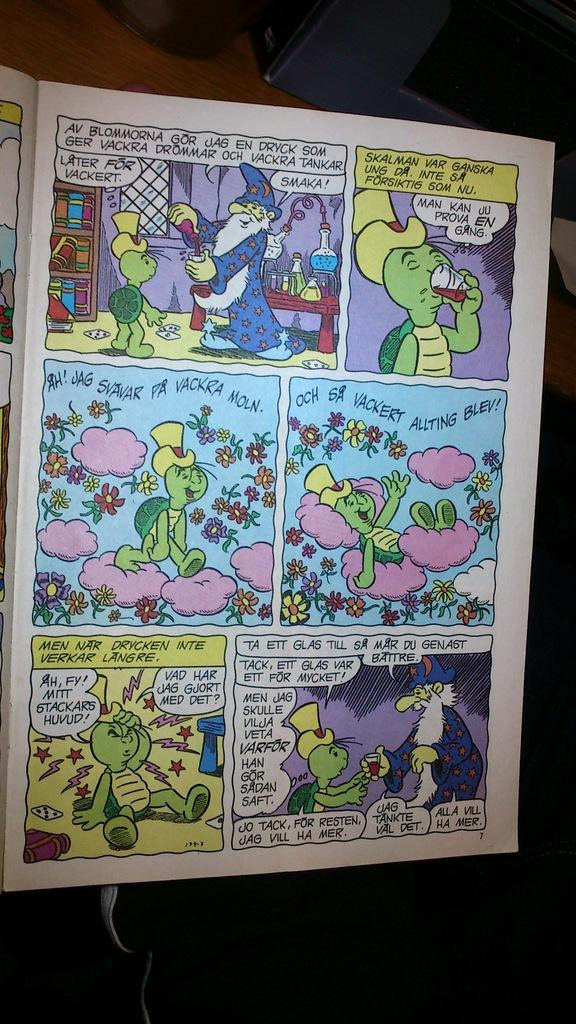<image>
Offer a succinct explanation of the picture presented. A foreign language comic book contains words like Vackert and Smaka. 